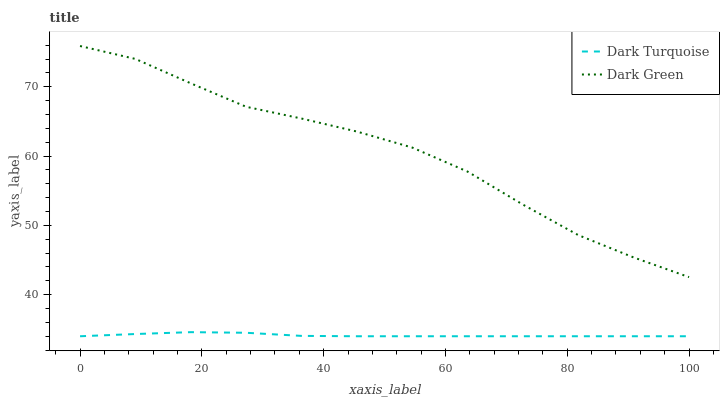Does Dark Turquoise have the minimum area under the curve?
Answer yes or no. Yes. Does Dark Green have the maximum area under the curve?
Answer yes or no. Yes. Does Dark Green have the minimum area under the curve?
Answer yes or no. No. Is Dark Turquoise the smoothest?
Answer yes or no. Yes. Is Dark Green the roughest?
Answer yes or no. Yes. Is Dark Green the smoothest?
Answer yes or no. No. Does Dark Turquoise have the lowest value?
Answer yes or no. Yes. Does Dark Green have the lowest value?
Answer yes or no. No. Does Dark Green have the highest value?
Answer yes or no. Yes. Is Dark Turquoise less than Dark Green?
Answer yes or no. Yes. Is Dark Green greater than Dark Turquoise?
Answer yes or no. Yes. Does Dark Turquoise intersect Dark Green?
Answer yes or no. No. 